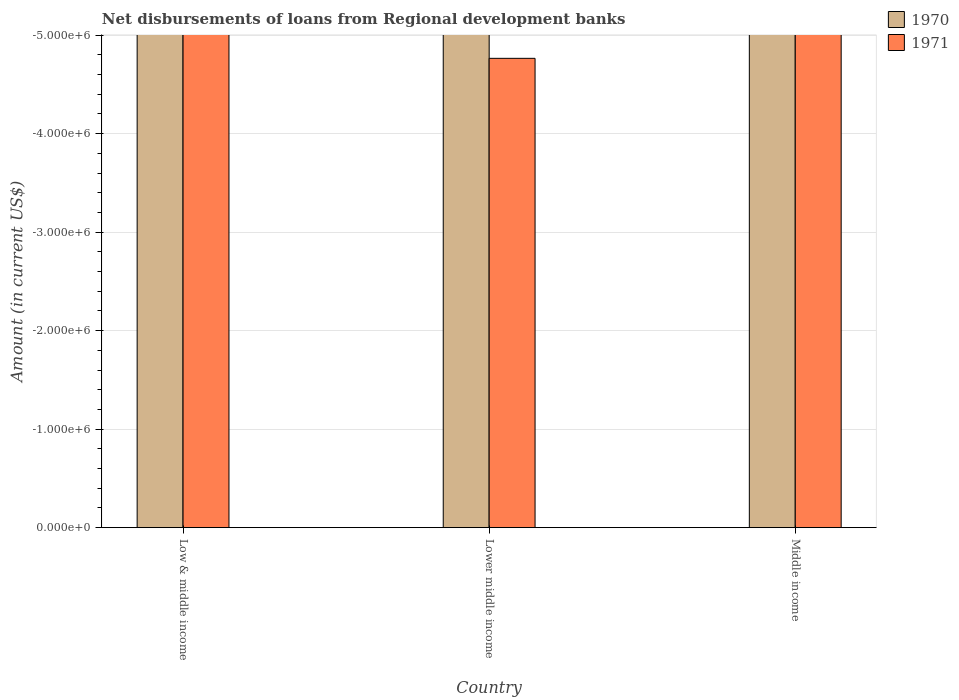Are the number of bars per tick equal to the number of legend labels?
Your answer should be compact. No. Are the number of bars on each tick of the X-axis equal?
Offer a terse response. Yes. How many bars are there on the 3rd tick from the left?
Provide a short and direct response. 0. How many bars are there on the 1st tick from the right?
Your response must be concise. 0. In how many cases, is the number of bars for a given country not equal to the number of legend labels?
Provide a succinct answer. 3. What is the total amount of disbursements of loans from regional development banks in 1971 in the graph?
Provide a succinct answer. 0. What is the average amount of disbursements of loans from regional development banks in 1970 per country?
Offer a terse response. 0. In how many countries, is the amount of disbursements of loans from regional development banks in 1971 greater than -2400000 US$?
Your response must be concise. 0. How many bars are there?
Your response must be concise. 0. Are all the bars in the graph horizontal?
Keep it short and to the point. No. How many countries are there in the graph?
Provide a succinct answer. 3. Are the values on the major ticks of Y-axis written in scientific E-notation?
Keep it short and to the point. Yes. Does the graph contain grids?
Make the answer very short. Yes. Where does the legend appear in the graph?
Your response must be concise. Top right. How many legend labels are there?
Offer a terse response. 2. What is the title of the graph?
Ensure brevity in your answer.  Net disbursements of loans from Regional development banks. Does "2009" appear as one of the legend labels in the graph?
Ensure brevity in your answer.  No. What is the label or title of the X-axis?
Ensure brevity in your answer.  Country. What is the Amount (in current US$) in 1970 in Low & middle income?
Offer a terse response. 0. What is the Amount (in current US$) of 1971 in Low & middle income?
Your answer should be compact. 0. What is the Amount (in current US$) of 1970 in Middle income?
Your response must be concise. 0. What is the Amount (in current US$) of 1971 in Middle income?
Your answer should be compact. 0. What is the total Amount (in current US$) in 1970 in the graph?
Provide a succinct answer. 0. What is the total Amount (in current US$) of 1971 in the graph?
Your response must be concise. 0. What is the average Amount (in current US$) of 1971 per country?
Make the answer very short. 0. 